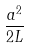<formula> <loc_0><loc_0><loc_500><loc_500>\frac { a ^ { 2 } } { 2 L }</formula> 